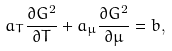<formula> <loc_0><loc_0><loc_500><loc_500>a _ { T } \frac { \partial G ^ { 2 } } { \partial T } + a _ { \mu } \frac { \partial G ^ { 2 } } { \partial \mu } = b ,</formula> 